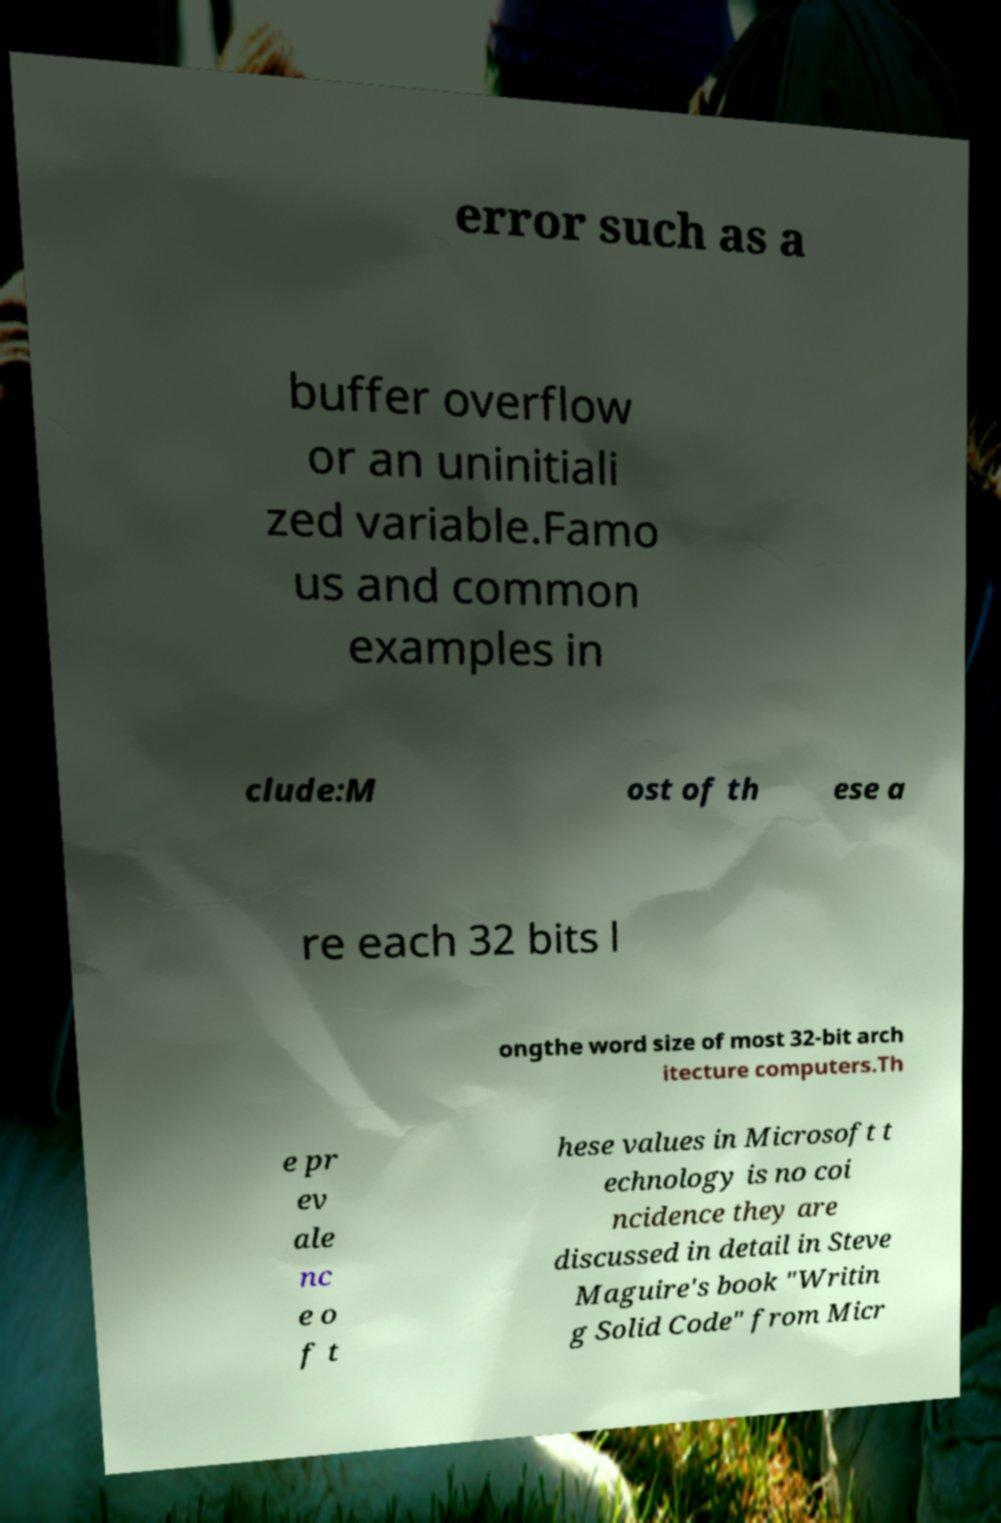Could you assist in decoding the text presented in this image and type it out clearly? error such as a buffer overflow or an uninitiali zed variable.Famo us and common examples in clude:M ost of th ese a re each 32 bits l ongthe word size of most 32-bit arch itecture computers.Th e pr ev ale nc e o f t hese values in Microsoft t echnology is no coi ncidence they are discussed in detail in Steve Maguire's book "Writin g Solid Code" from Micr 